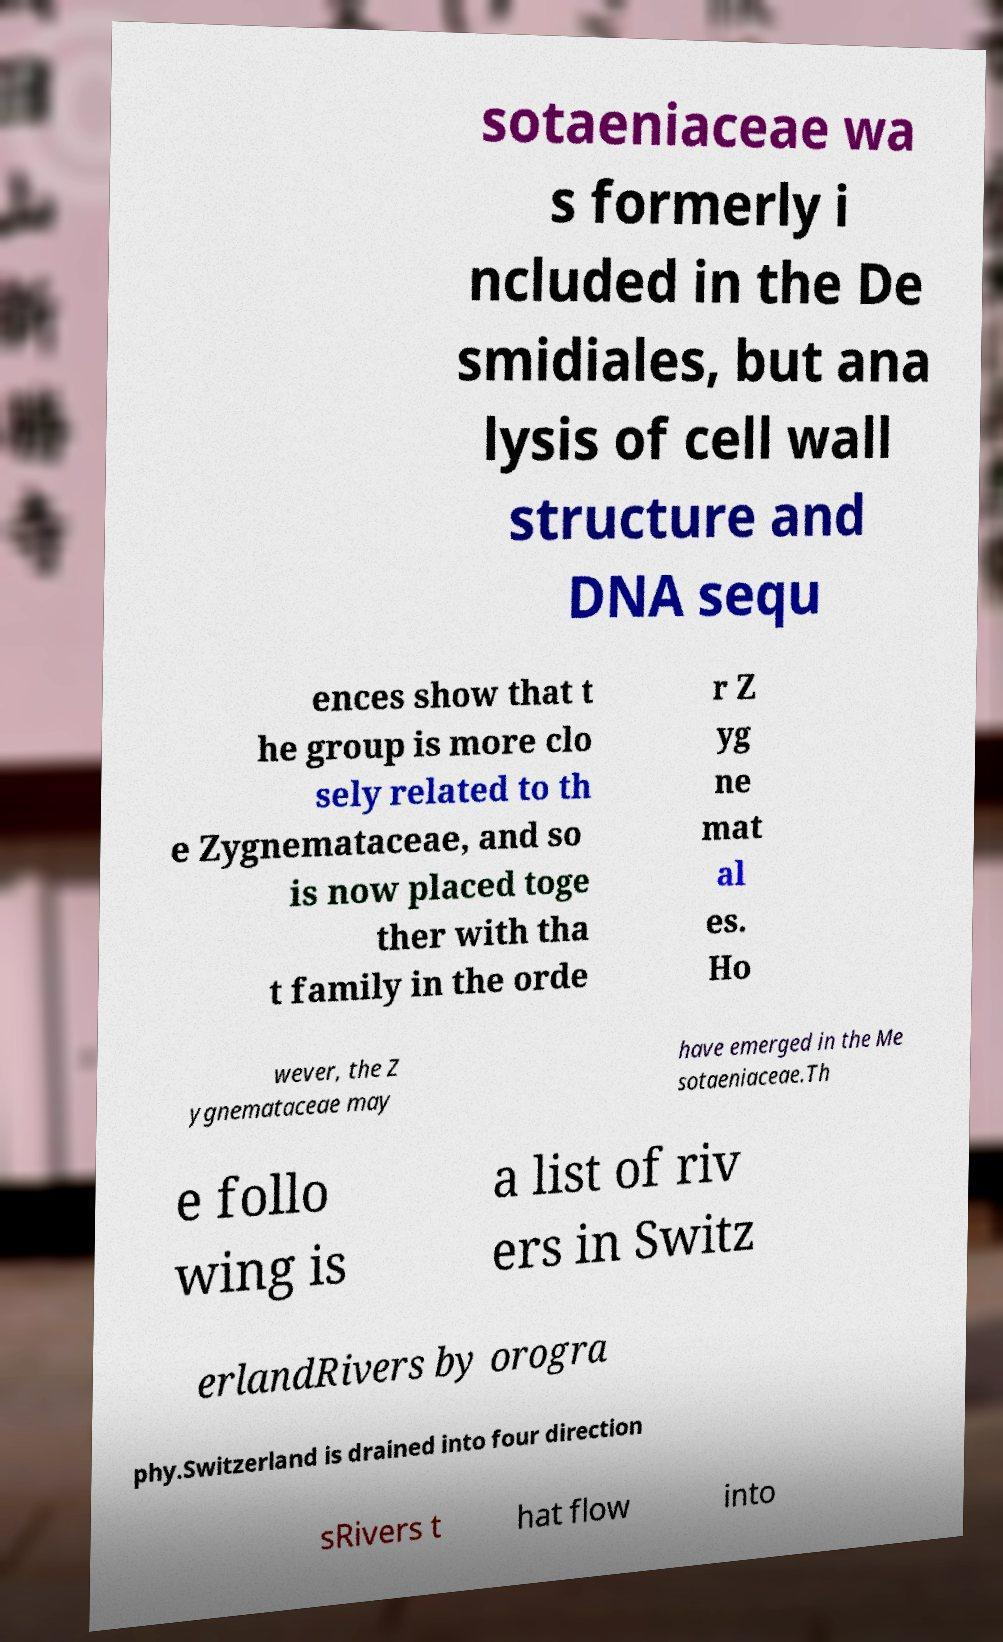Could you extract and type out the text from this image? sotaeniaceae wa s formerly i ncluded in the De smidiales, but ana lysis of cell wall structure and DNA sequ ences show that t he group is more clo sely related to th e Zygnemataceae, and so is now placed toge ther with tha t family in the orde r Z yg ne mat al es. Ho wever, the Z ygnemataceae may have emerged in the Me sotaeniaceae.Th e follo wing is a list of riv ers in Switz erlandRivers by orogra phy.Switzerland is drained into four direction sRivers t hat flow into 